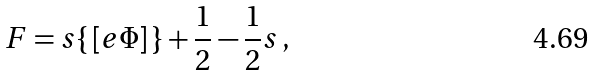<formula> <loc_0><loc_0><loc_500><loc_500>F = s \{ \, [ e \Phi ] \, \} + \frac { 1 } { 2 } - \frac { 1 } { 2 } s \, ,</formula> 